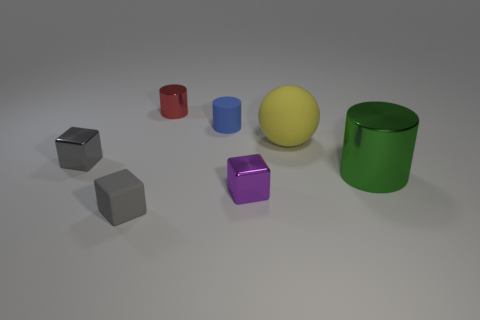Subtract 2 cubes. How many cubes are left? 1 Subtract all small metallic blocks. How many blocks are left? 1 Add 2 cyan shiny objects. How many objects exist? 9 Subtract 0 cyan cylinders. How many objects are left? 7 Subtract all cubes. How many objects are left? 4 Subtract all blue cylinders. Subtract all red spheres. How many cylinders are left? 2 Subtract all gray cubes. How many red cylinders are left? 1 Subtract all large gray rubber cylinders. Subtract all tiny cylinders. How many objects are left? 5 Add 6 large green cylinders. How many large green cylinders are left? 7 Add 7 large matte blocks. How many large matte blocks exist? 7 